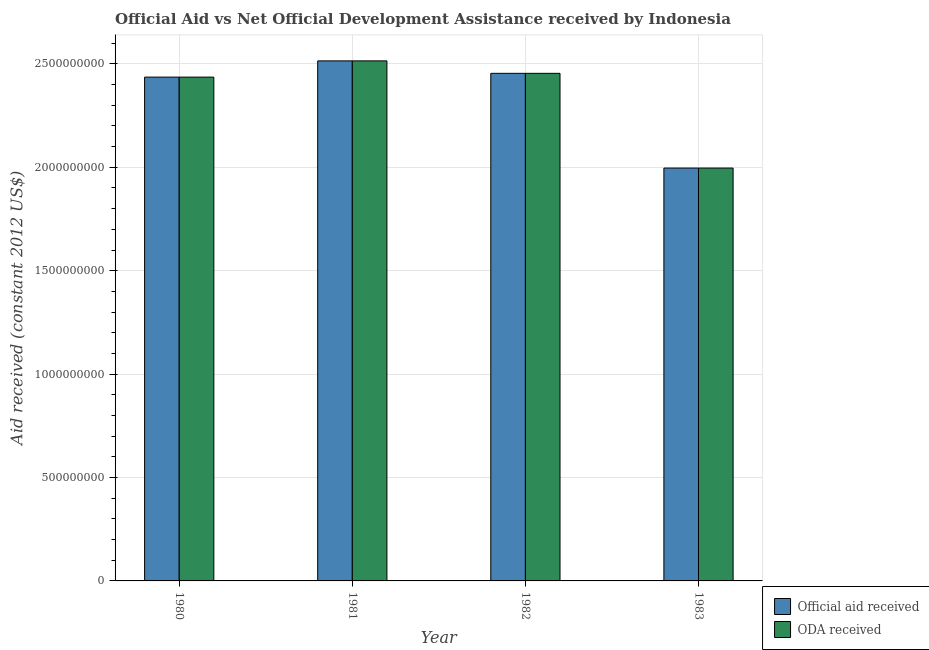How many different coloured bars are there?
Keep it short and to the point. 2. Are the number of bars on each tick of the X-axis equal?
Offer a very short reply. Yes. How many bars are there on the 4th tick from the right?
Your answer should be compact. 2. What is the oda received in 1983?
Make the answer very short. 2.00e+09. Across all years, what is the maximum oda received?
Provide a succinct answer. 2.51e+09. Across all years, what is the minimum oda received?
Your response must be concise. 2.00e+09. In which year was the official aid received maximum?
Your answer should be very brief. 1981. What is the total oda received in the graph?
Provide a succinct answer. 9.40e+09. What is the difference between the official aid received in 1980 and that in 1982?
Make the answer very short. -1.82e+07. What is the difference between the official aid received in 1980 and the oda received in 1983?
Your answer should be compact. 4.40e+08. What is the average oda received per year?
Your response must be concise. 2.35e+09. In how many years, is the official aid received greater than 1700000000 US$?
Your response must be concise. 4. What is the ratio of the oda received in 1980 to that in 1981?
Offer a very short reply. 0.97. Is the difference between the oda received in 1981 and 1982 greater than the difference between the official aid received in 1981 and 1982?
Offer a terse response. No. What is the difference between the highest and the second highest oda received?
Your answer should be compact. 6.02e+07. What is the difference between the highest and the lowest oda received?
Your answer should be very brief. 5.18e+08. In how many years, is the official aid received greater than the average official aid received taken over all years?
Your response must be concise. 3. Is the sum of the official aid received in 1982 and 1983 greater than the maximum oda received across all years?
Offer a terse response. Yes. What does the 1st bar from the left in 1980 represents?
Offer a terse response. Official aid received. What does the 1st bar from the right in 1982 represents?
Offer a very short reply. ODA received. How many bars are there?
Provide a short and direct response. 8. Are all the bars in the graph horizontal?
Make the answer very short. No. How many years are there in the graph?
Offer a terse response. 4. Does the graph contain any zero values?
Give a very brief answer. No. How many legend labels are there?
Give a very brief answer. 2. What is the title of the graph?
Offer a very short reply. Official Aid vs Net Official Development Assistance received by Indonesia . What is the label or title of the X-axis?
Your answer should be compact. Year. What is the label or title of the Y-axis?
Provide a succinct answer. Aid received (constant 2012 US$). What is the Aid received (constant 2012 US$) in Official aid received in 1980?
Your answer should be compact. 2.44e+09. What is the Aid received (constant 2012 US$) in ODA received in 1980?
Offer a very short reply. 2.44e+09. What is the Aid received (constant 2012 US$) in Official aid received in 1981?
Ensure brevity in your answer.  2.51e+09. What is the Aid received (constant 2012 US$) of ODA received in 1981?
Your answer should be compact. 2.51e+09. What is the Aid received (constant 2012 US$) in Official aid received in 1982?
Offer a very short reply. 2.45e+09. What is the Aid received (constant 2012 US$) of ODA received in 1982?
Give a very brief answer. 2.45e+09. What is the Aid received (constant 2012 US$) in Official aid received in 1983?
Offer a terse response. 2.00e+09. What is the Aid received (constant 2012 US$) in ODA received in 1983?
Give a very brief answer. 2.00e+09. Across all years, what is the maximum Aid received (constant 2012 US$) of Official aid received?
Your response must be concise. 2.51e+09. Across all years, what is the maximum Aid received (constant 2012 US$) in ODA received?
Your answer should be very brief. 2.51e+09. Across all years, what is the minimum Aid received (constant 2012 US$) in Official aid received?
Your response must be concise. 2.00e+09. Across all years, what is the minimum Aid received (constant 2012 US$) in ODA received?
Your answer should be very brief. 2.00e+09. What is the total Aid received (constant 2012 US$) in Official aid received in the graph?
Offer a terse response. 9.40e+09. What is the total Aid received (constant 2012 US$) in ODA received in the graph?
Your answer should be very brief. 9.40e+09. What is the difference between the Aid received (constant 2012 US$) of Official aid received in 1980 and that in 1981?
Make the answer very short. -7.85e+07. What is the difference between the Aid received (constant 2012 US$) in ODA received in 1980 and that in 1981?
Offer a terse response. -7.85e+07. What is the difference between the Aid received (constant 2012 US$) in Official aid received in 1980 and that in 1982?
Provide a succinct answer. -1.82e+07. What is the difference between the Aid received (constant 2012 US$) of ODA received in 1980 and that in 1982?
Offer a very short reply. -1.82e+07. What is the difference between the Aid received (constant 2012 US$) of Official aid received in 1980 and that in 1983?
Your answer should be very brief. 4.40e+08. What is the difference between the Aid received (constant 2012 US$) in ODA received in 1980 and that in 1983?
Make the answer very short. 4.40e+08. What is the difference between the Aid received (constant 2012 US$) of Official aid received in 1981 and that in 1982?
Keep it short and to the point. 6.02e+07. What is the difference between the Aid received (constant 2012 US$) in ODA received in 1981 and that in 1982?
Ensure brevity in your answer.  6.02e+07. What is the difference between the Aid received (constant 2012 US$) of Official aid received in 1981 and that in 1983?
Provide a short and direct response. 5.18e+08. What is the difference between the Aid received (constant 2012 US$) in ODA received in 1981 and that in 1983?
Make the answer very short. 5.18e+08. What is the difference between the Aid received (constant 2012 US$) of Official aid received in 1982 and that in 1983?
Offer a very short reply. 4.58e+08. What is the difference between the Aid received (constant 2012 US$) of ODA received in 1982 and that in 1983?
Provide a succinct answer. 4.58e+08. What is the difference between the Aid received (constant 2012 US$) in Official aid received in 1980 and the Aid received (constant 2012 US$) in ODA received in 1981?
Your answer should be very brief. -7.85e+07. What is the difference between the Aid received (constant 2012 US$) of Official aid received in 1980 and the Aid received (constant 2012 US$) of ODA received in 1982?
Provide a succinct answer. -1.82e+07. What is the difference between the Aid received (constant 2012 US$) of Official aid received in 1980 and the Aid received (constant 2012 US$) of ODA received in 1983?
Offer a very short reply. 4.40e+08. What is the difference between the Aid received (constant 2012 US$) in Official aid received in 1981 and the Aid received (constant 2012 US$) in ODA received in 1982?
Your response must be concise. 6.02e+07. What is the difference between the Aid received (constant 2012 US$) of Official aid received in 1981 and the Aid received (constant 2012 US$) of ODA received in 1983?
Your answer should be very brief. 5.18e+08. What is the difference between the Aid received (constant 2012 US$) of Official aid received in 1982 and the Aid received (constant 2012 US$) of ODA received in 1983?
Your answer should be compact. 4.58e+08. What is the average Aid received (constant 2012 US$) in Official aid received per year?
Give a very brief answer. 2.35e+09. What is the average Aid received (constant 2012 US$) of ODA received per year?
Offer a terse response. 2.35e+09. In the year 1980, what is the difference between the Aid received (constant 2012 US$) in Official aid received and Aid received (constant 2012 US$) in ODA received?
Your answer should be very brief. 0. What is the ratio of the Aid received (constant 2012 US$) in Official aid received in 1980 to that in 1981?
Make the answer very short. 0.97. What is the ratio of the Aid received (constant 2012 US$) of ODA received in 1980 to that in 1981?
Ensure brevity in your answer.  0.97. What is the ratio of the Aid received (constant 2012 US$) of Official aid received in 1980 to that in 1983?
Provide a short and direct response. 1.22. What is the ratio of the Aid received (constant 2012 US$) in ODA received in 1980 to that in 1983?
Your answer should be very brief. 1.22. What is the ratio of the Aid received (constant 2012 US$) of Official aid received in 1981 to that in 1982?
Provide a short and direct response. 1.02. What is the ratio of the Aid received (constant 2012 US$) in ODA received in 1981 to that in 1982?
Ensure brevity in your answer.  1.02. What is the ratio of the Aid received (constant 2012 US$) of Official aid received in 1981 to that in 1983?
Offer a terse response. 1.26. What is the ratio of the Aid received (constant 2012 US$) of ODA received in 1981 to that in 1983?
Ensure brevity in your answer.  1.26. What is the ratio of the Aid received (constant 2012 US$) of Official aid received in 1982 to that in 1983?
Provide a short and direct response. 1.23. What is the ratio of the Aid received (constant 2012 US$) of ODA received in 1982 to that in 1983?
Ensure brevity in your answer.  1.23. What is the difference between the highest and the second highest Aid received (constant 2012 US$) in Official aid received?
Provide a succinct answer. 6.02e+07. What is the difference between the highest and the second highest Aid received (constant 2012 US$) of ODA received?
Your response must be concise. 6.02e+07. What is the difference between the highest and the lowest Aid received (constant 2012 US$) of Official aid received?
Give a very brief answer. 5.18e+08. What is the difference between the highest and the lowest Aid received (constant 2012 US$) of ODA received?
Offer a terse response. 5.18e+08. 